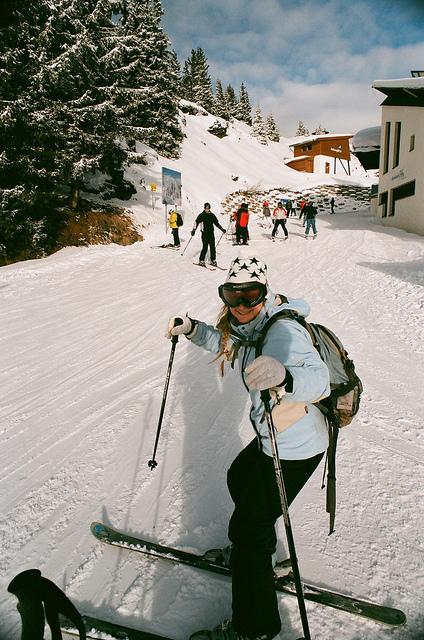What is she wearing on her back?
Give a very brief answer. Backpack. What color is the lady's coat?
Give a very brief answer. Blue. What color is the girl's pants?
Answer briefly. Black. What is the person doing?
Quick response, please. Skiing. 